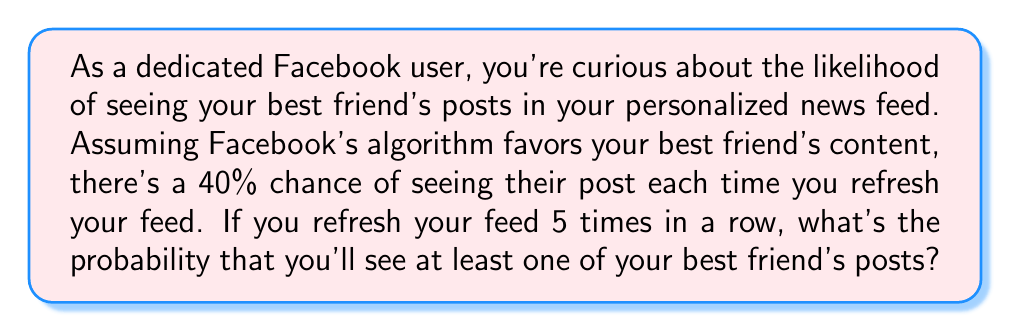Can you answer this question? Let's approach this step-by-step:

1) First, we need to recognize that this is a binomial probability problem. We're looking for the probability of at least one success in 5 trials.

2) It's often easier to calculate the probability of the complement event (not seeing any posts) and then subtract from 1.

3) The probability of not seeing a post on a single refresh is $1 - 0.40 = 0.60$ or 60%.

4) For not seeing any posts in 5 refreshes, we need this to happen 5 times in a row. We can calculate this as:

   $$(0.60)^5 = 0.07776$$

5) This means the probability of not seeing any posts in 5 refreshes is about 0.07776 or 7.776%.

6) Therefore, the probability of seeing at least one post is:

   $$1 - (0.60)^5 = 1 - 0.07776 = 0.92224$$

7) We can also express this using the binomial probability formula:

   $$P(X \geq 1) = 1 - P(X = 0) = 1 - \binom{5}{0}(0.40)^0(0.60)^5 = 0.92224$$

So, there's a 92.224% chance of seeing at least one of your best friend's posts in 5 refreshes.
Answer: 0.92224 or 92.224% 